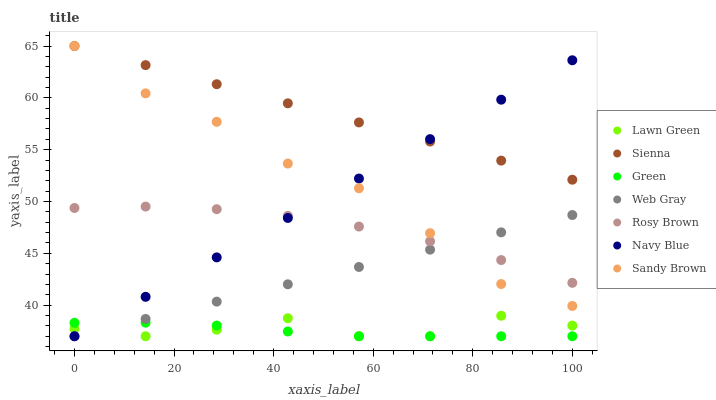Does Green have the minimum area under the curve?
Answer yes or no. Yes. Does Sienna have the maximum area under the curve?
Answer yes or no. Yes. Does Web Gray have the minimum area under the curve?
Answer yes or no. No. Does Web Gray have the maximum area under the curve?
Answer yes or no. No. Is Sienna the smoothest?
Answer yes or no. Yes. Is Lawn Green the roughest?
Answer yes or no. Yes. Is Web Gray the smoothest?
Answer yes or no. No. Is Web Gray the roughest?
Answer yes or no. No. Does Lawn Green have the lowest value?
Answer yes or no. Yes. Does Rosy Brown have the lowest value?
Answer yes or no. No. Does Sandy Brown have the highest value?
Answer yes or no. Yes. Does Web Gray have the highest value?
Answer yes or no. No. Is Green less than Rosy Brown?
Answer yes or no. Yes. Is Sienna greater than Web Gray?
Answer yes or no. Yes. Does Sandy Brown intersect Navy Blue?
Answer yes or no. Yes. Is Sandy Brown less than Navy Blue?
Answer yes or no. No. Is Sandy Brown greater than Navy Blue?
Answer yes or no. No. Does Green intersect Rosy Brown?
Answer yes or no. No. 